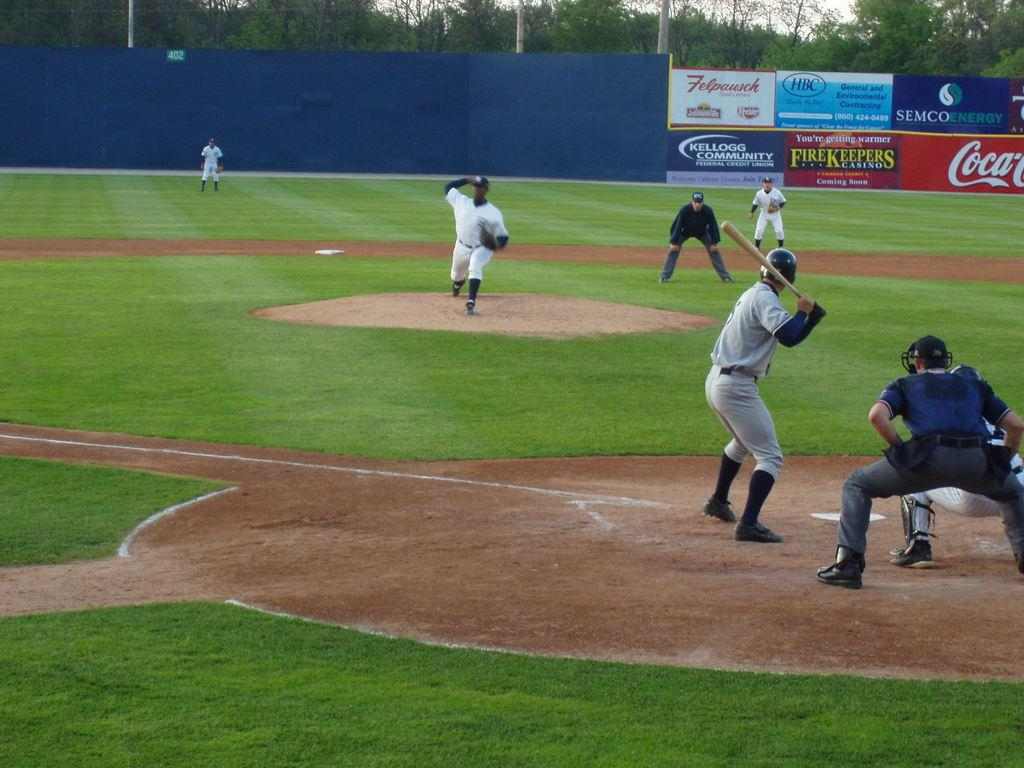What sport are the people playing in the image? The people are playing a baseball game in the image. What is the man holding in the image? The man is holding a bat in the image. What can be seen in the background of the image? There are hoardings and trees in the background of the image. What is the chance of the lock being smashed in the image? There is no lock present in the image, so it is not possible to determine the chance of it being smashed. 